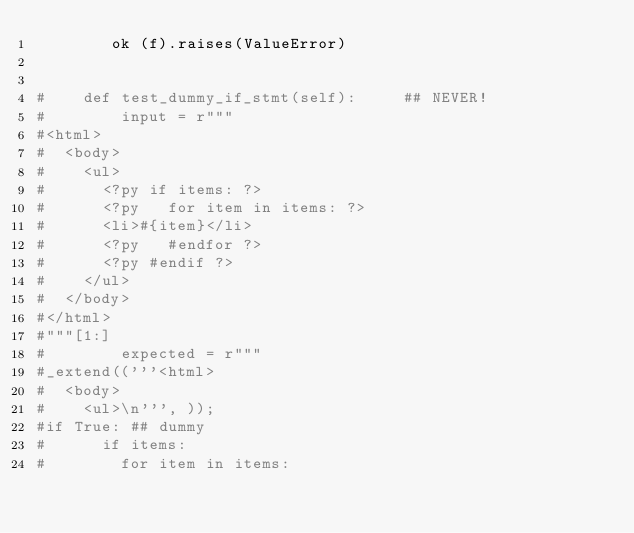Convert code to text. <code><loc_0><loc_0><loc_500><loc_500><_Python_>        ok (f).raises(ValueError)


#    def test_dummy_if_stmt(self):     ## NEVER!
#        input = r"""
#<html>
#  <body>
#    <ul>
#      <?py if items: ?>
#      <?py   for item in items: ?>
#      <li>#{item}</li>
#      <?py   #endfor ?>
#      <?py #endif ?>
#    </ul>
#  </body>
#</html>
#"""[1:]
#        expected = r"""
#_extend(('''<html>
#  <body>
#    <ul>\n''', ));
#if True: ## dummy
#      if items:
#        for item in items:</code> 